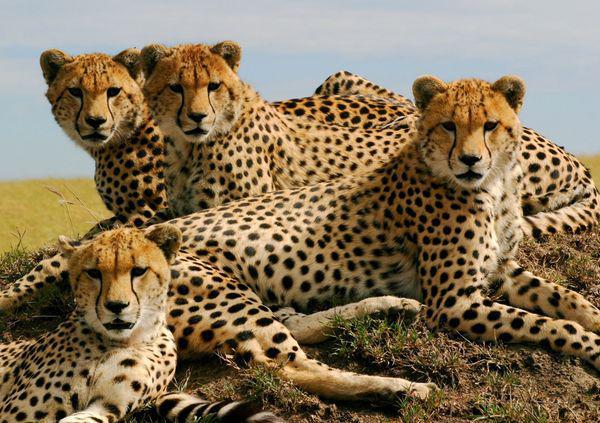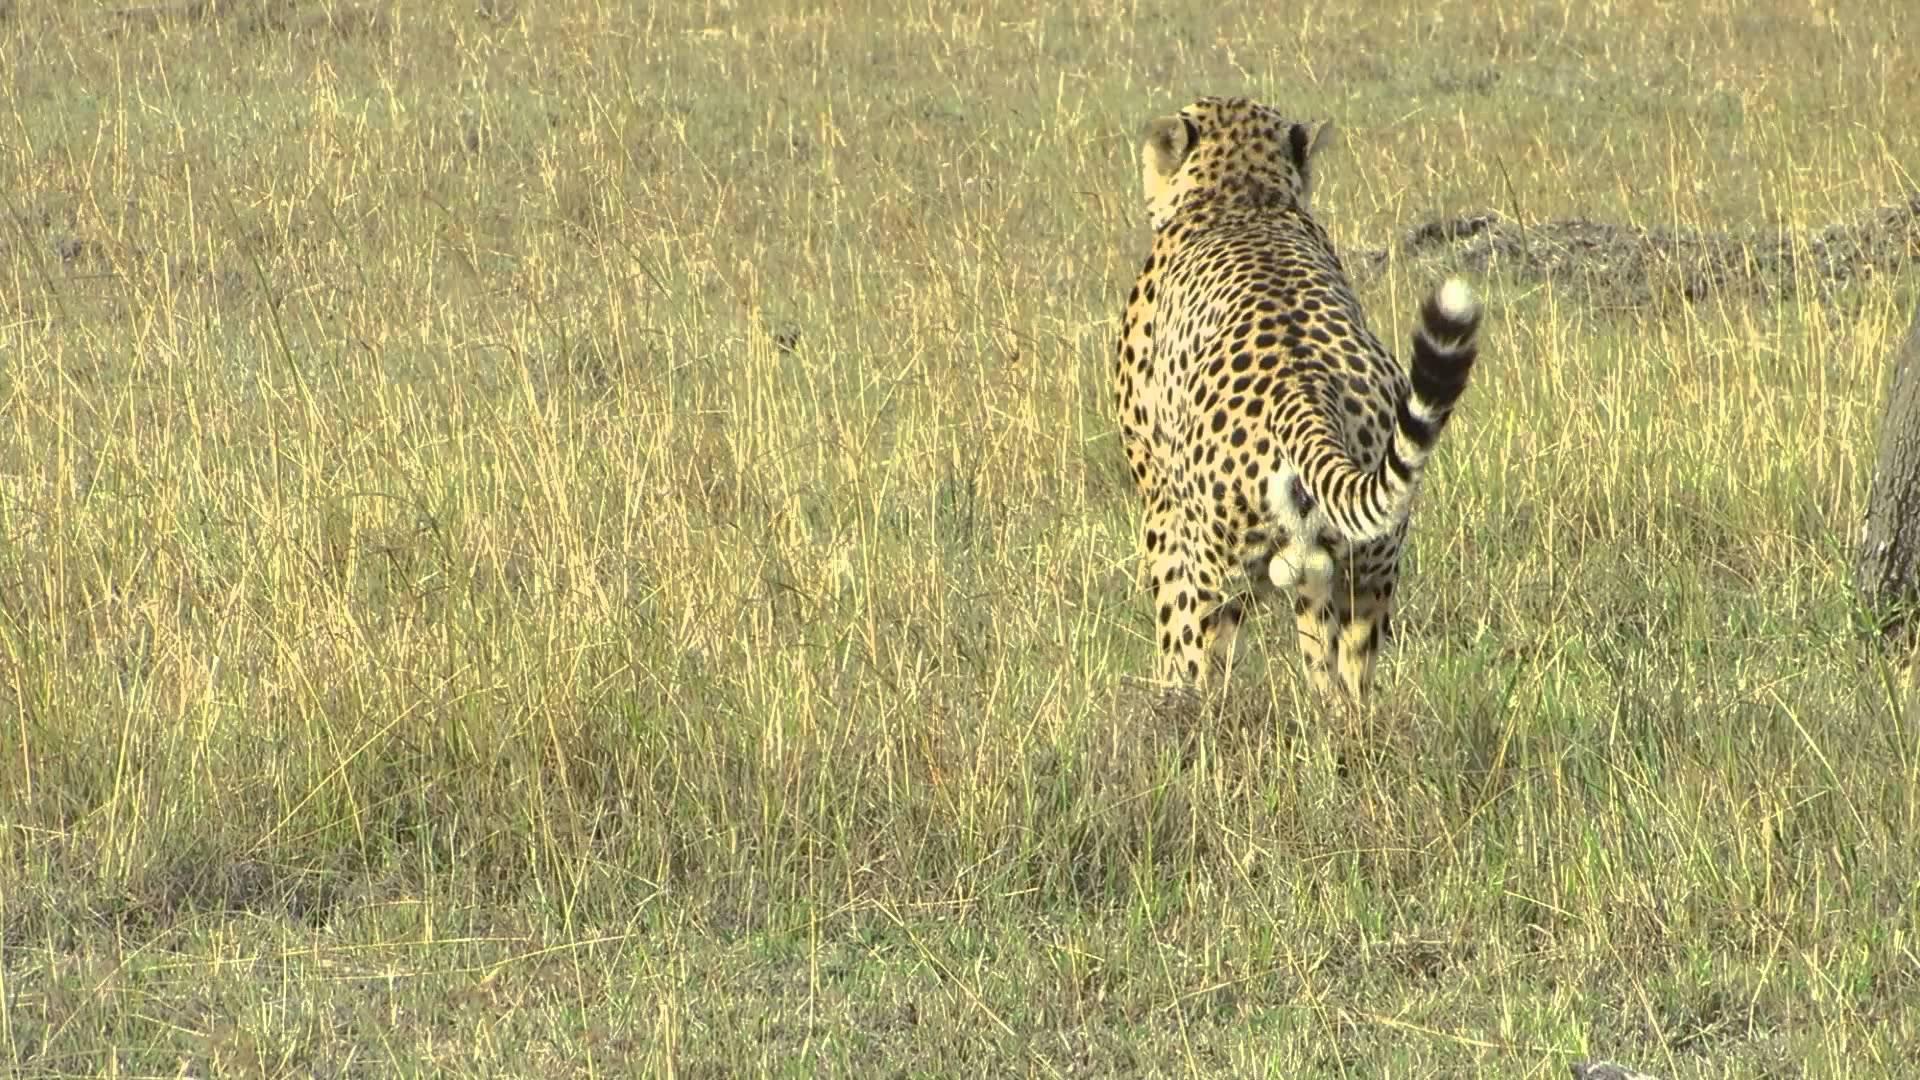The first image is the image on the left, the second image is the image on the right. For the images shown, is this caption "The left photo contains three or more cheetahs." true? Answer yes or no. Yes. The first image is the image on the left, the second image is the image on the right. Considering the images on both sides, is "More than one cat in the image on the left is lying down." valid? Answer yes or no. Yes. 